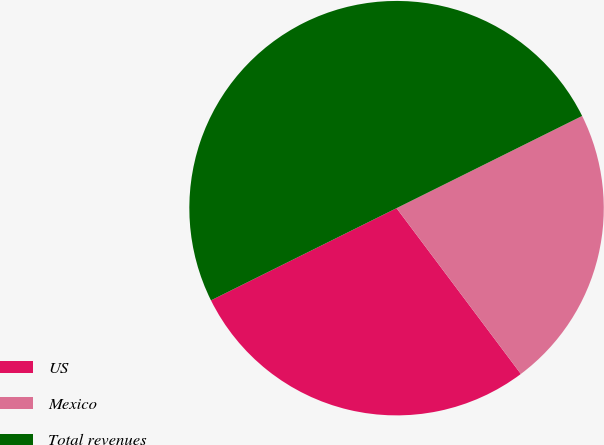<chart> <loc_0><loc_0><loc_500><loc_500><pie_chart><fcel>US<fcel>Mexico<fcel>Total revenues<nl><fcel>27.9%<fcel>22.1%<fcel>50.0%<nl></chart> 